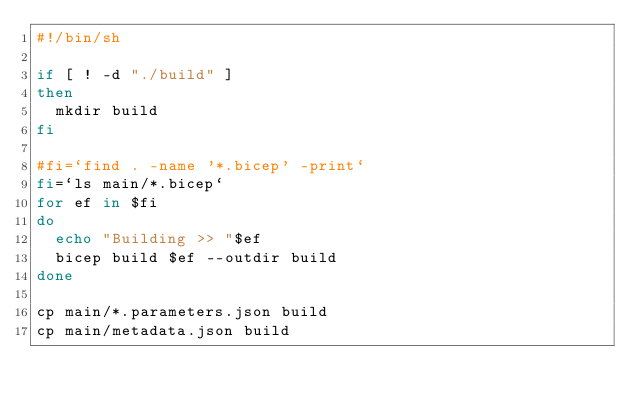<code> <loc_0><loc_0><loc_500><loc_500><_Bash_>#!/bin/sh

if [ ! -d "./build" ] 
then
  mkdir build
fi

#fi=`find . -name '*.bicep' -print`
fi=`ls main/*.bicep`
for ef in $fi
do
  echo "Building >> "$ef
  bicep build $ef --outdir build
done

cp main/*.parameters.json build
cp main/metadata.json build</code> 